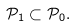Convert formula to latex. <formula><loc_0><loc_0><loc_500><loc_500>\mathcal { P } _ { 1 } \subset \mathcal { P } _ { 0 } .</formula> 